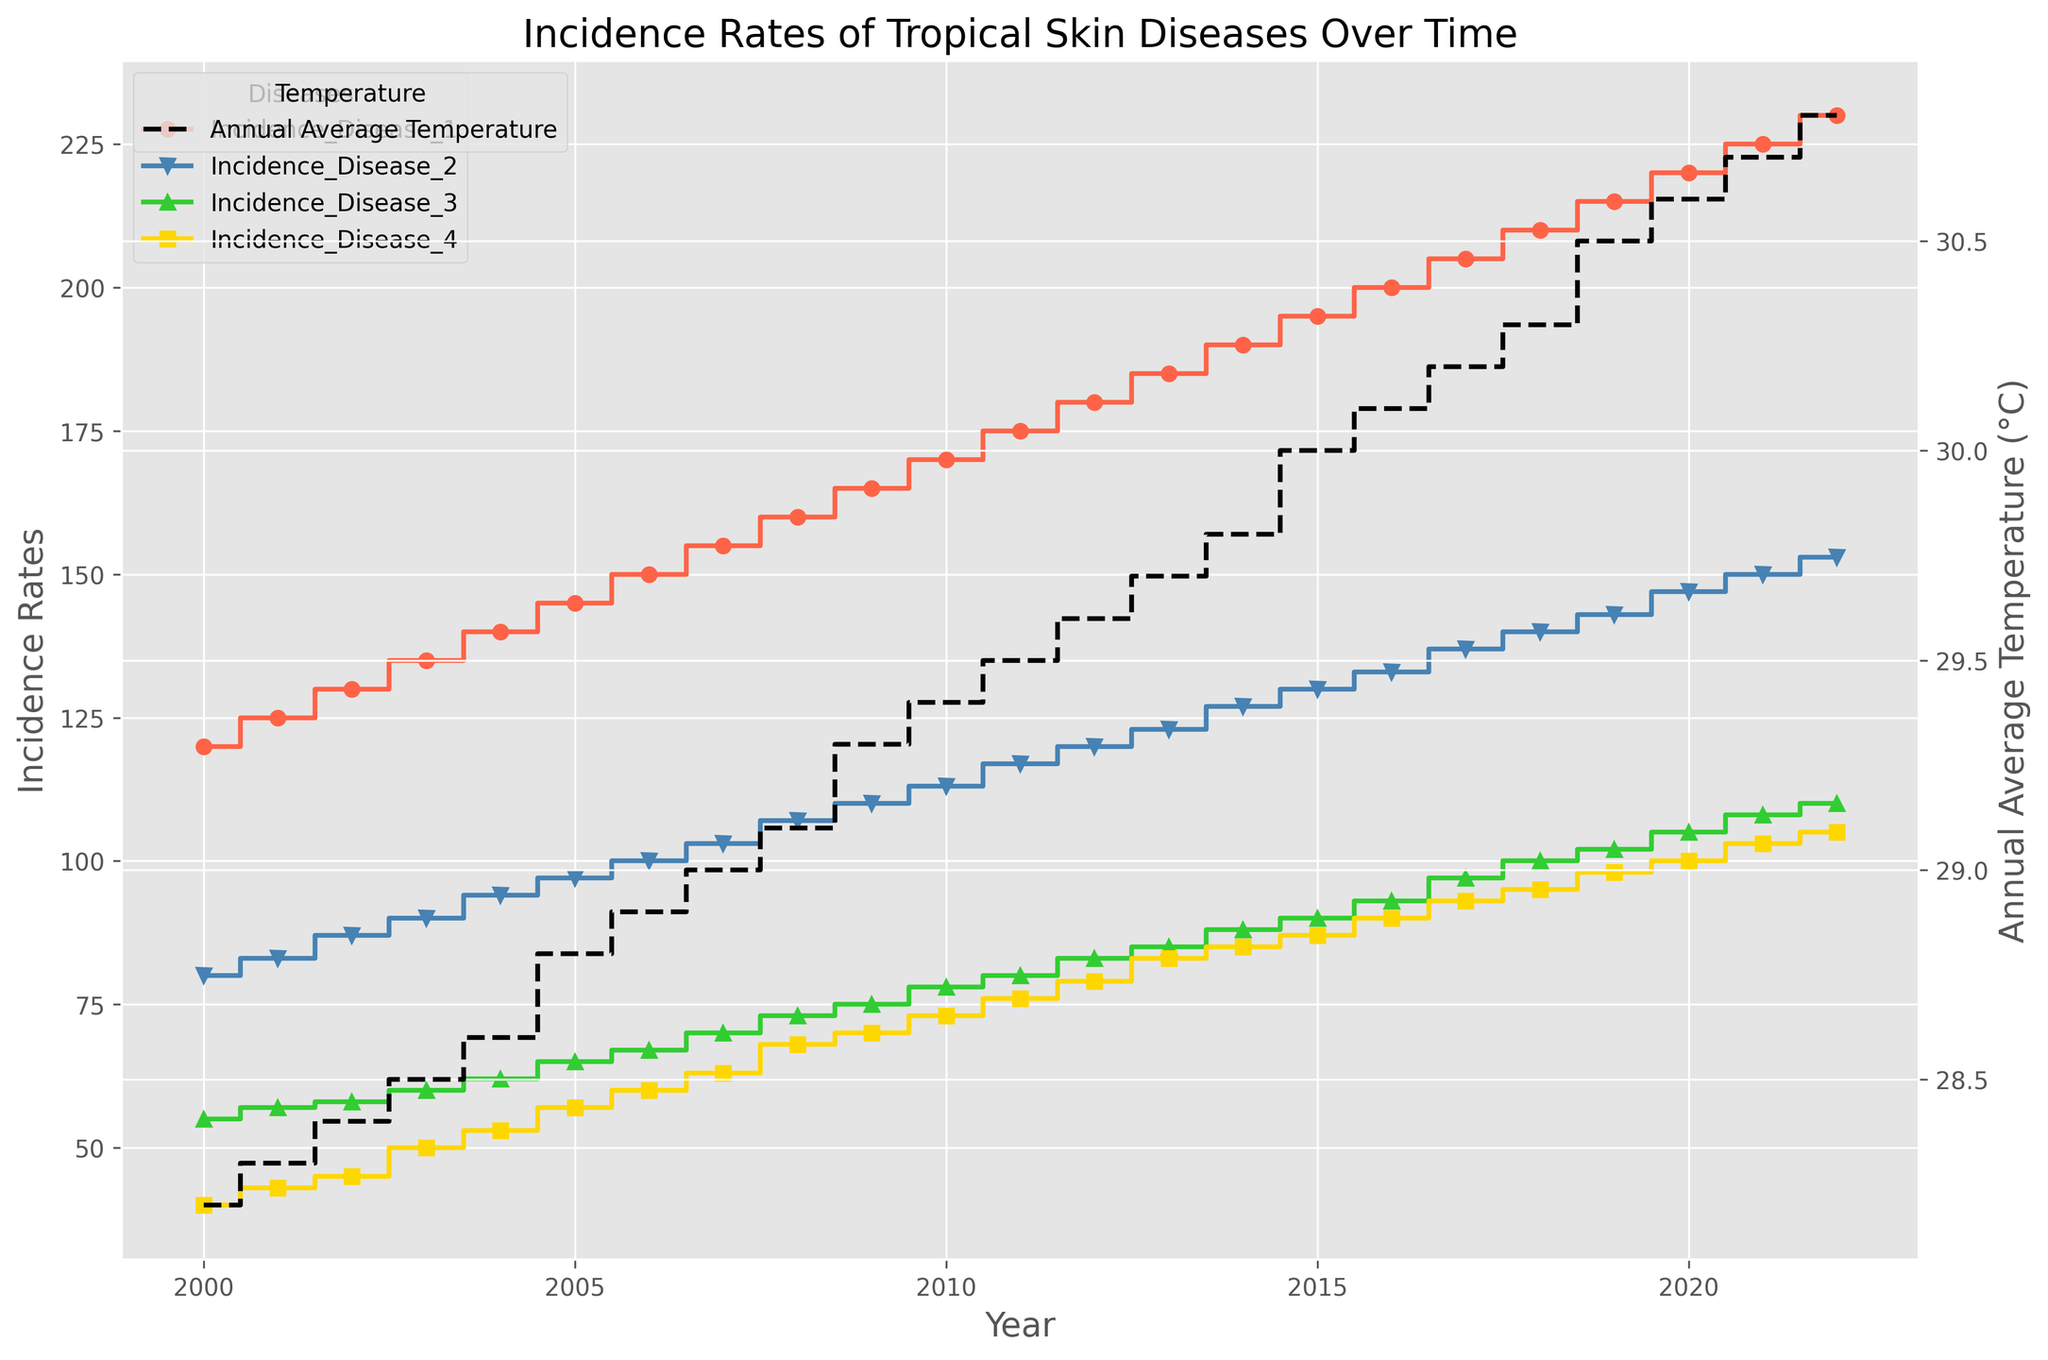What is the incidence rate of Disease 1 in the year 2010? Look for the data points corresponding to Disease 1 and find the incidence rate value for the year 2010 in the plot.
Answer: 170 Which tropical skin disease had the highest incidence rate in 2022? Compare the incidence rates of all four diseases for the year 2022 to determine which one was the highest.
Answer: Disease 1 How did the incidence rate of Disease 2 change from 2000 to 2022? Look at the incidence rate of Disease 2 in the years 2000 and 2022 and observe the trend. The rate increased from 80 to 153.
Answer: Increased In which year did the average annual temperature reach 30.0°C and what were the incidence rates of the diseases in that year? Identify the year when the temperature first hit 30.0°C and note the corresponding incidence rates for all diseases. In 2015, Disease 1: 195, Disease 2: 130, Disease 3: 90, Disease 4: 87.
Answer: 2015: 195, 130, 90, 87 Are there any years where the incidence rates of Disease 3 and Disease 4 were equal? Compare the incidence rates of Disease 3 and Disease 4 across all years to check for any equal values.
Answer: No, they were never equal By how much did the incidence rate of Disease 1 increase from 2000 to 2022, and what was the average annual temperature change over the same period? Subtract the incidence rate of Disease 1 in 2000 from its rate in 2022 and calculate the difference in temperatures for the same years (230 - 120 for incidence rate and 30.8 - 28.2 for temperature).
Answer: 110; 2.6°C In which year did all four tropical skin diseases have the least combined incidence rate, and what was that rate? Add up the incidence rates for each disease per year and find the year with the smallest sum. For 2000, the combined rate is 120 + 80 + 55 + 40 = 295. This is the lowest combined incidence rate.
Answer: 2000: 295 What is the visual trend of the incidence rates and annual average temperature over the years? Analyze the visual slope and overall trendlines of the incidence rates and annual average temperature in the plot, noting that both are increasing over the years.
Answer: Increasing How does the visual representation of Disease 1 differ from Disease 4 in terms of color and marker? Observe the plot and identify the colors and markers used for Disease 1 (red, circles) and Disease 4 (yellow, squares).
Answer: Red circles vs. Yellow squares 